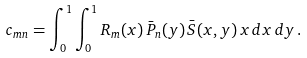<formula> <loc_0><loc_0><loc_500><loc_500>c _ { m n } = \int _ { 0 } ^ { 1 } \int _ { 0 } ^ { 1 } R _ { m } ( x ) \, \bar { P } _ { n } ( y ) \, \bar { S } ( x , y ) \, x \, d x \, d y \, .</formula> 